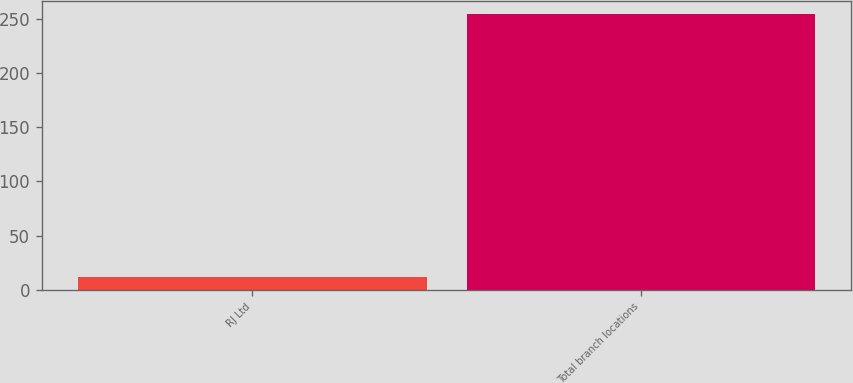Convert chart to OTSL. <chart><loc_0><loc_0><loc_500><loc_500><bar_chart><fcel>RJ Ltd<fcel>Total branch locations<nl><fcel>12<fcel>254<nl></chart> 